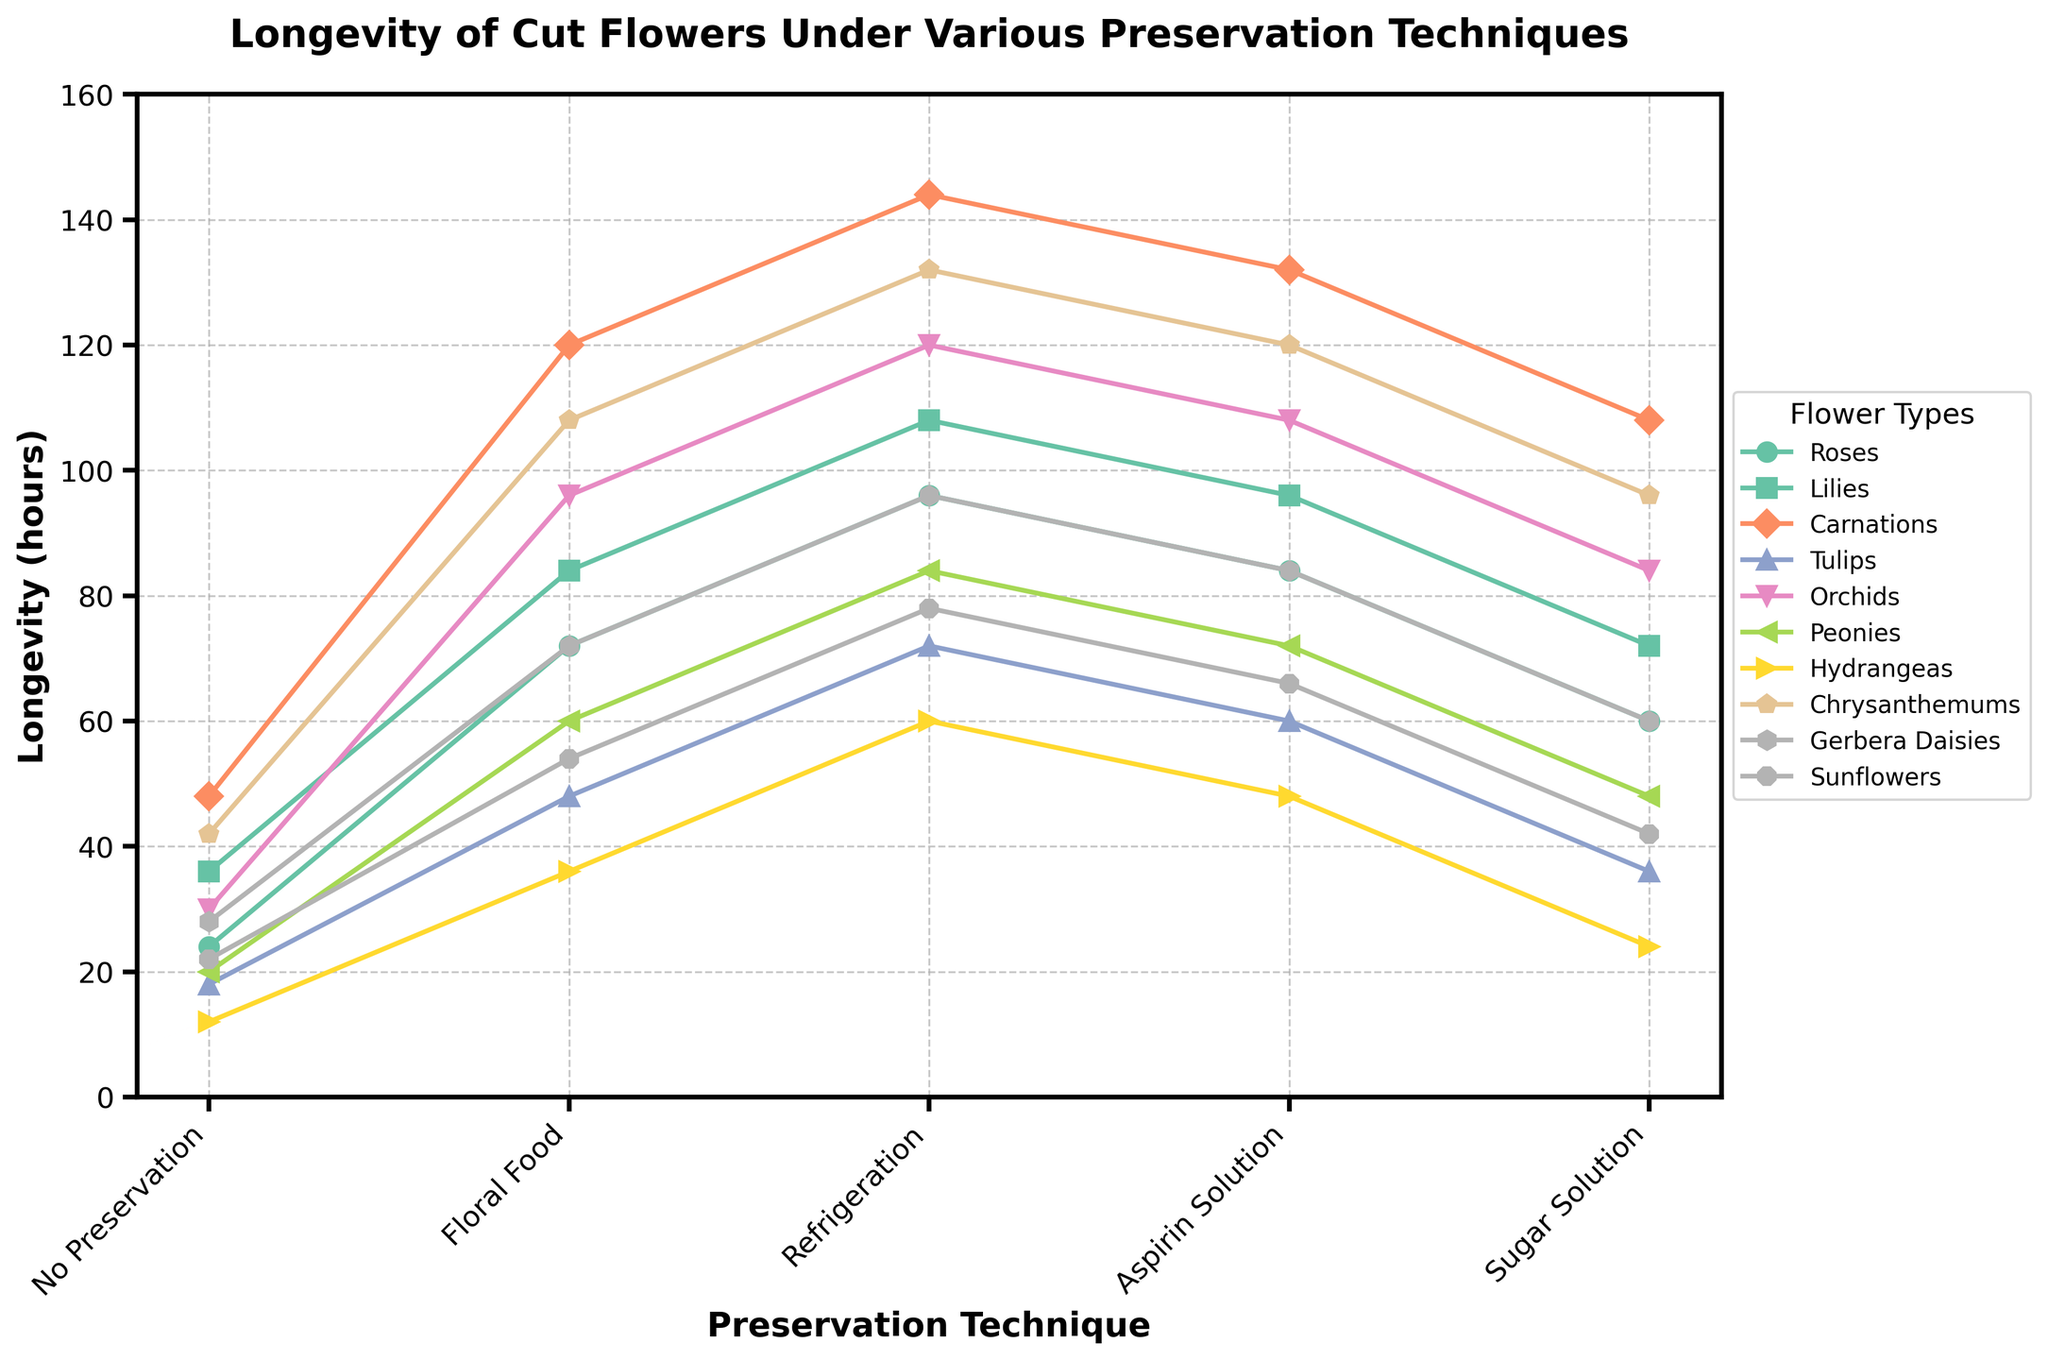Which flower type has the highest longevity with no preservation? Look at the section of the lines corresponding to 'No Preservation' and identify the flower type with the highest value. Carnations have the highest number, which is 48 hours.
Answer: Carnations Which technique provides the maximum longevity for Lilies? Refer to the line representing Lilies and find the peak value. The highest longevity for Lilies is 108 hours under Refrigeration.
Answer: Refrigeration What is the difference in longevity between Tulips with floral food and no preservation? Find the Tulips line, note values under floral food (48 hours) and no preservation (18 hours), and compute the difference: 48 - 18.
Answer: 30 hours Which preservation technique seems most effective overall? Compare the peaks of all preservation techniques; Refrigeration displays the highest values consistently for most flowers.
Answer: Refrigeration Calculate the average longevity of Roses across all preservation techniques. Sum the longevity values for Roses under each technique (24 + 72 + 96 + 84 + 60) = 336. Divide by the number of techniques (336/5).
Answer: 67.2 hours Do Sunflowers last longer with a sugar solution or refrigeration? For the Sunflower line, compare values under sugar solution (42 hours) vs refrigeration (78 hours). Refrigeration provides longer longevity.
Answer: Refrigeration Which flower type shows the greatest improvement in longevity when using refrigeration as opposed to no preservation? Subtract no preservation value from refrigeration for each flower type, and find the maximum difference. For Hydrangeas, this difference is the greatest: 60 - 12 = 48 hours.
Answer: Hydrangeas On average, how much longer do Carnations last under refrigeration compared to no preservation? Subtract the longevities for no preservation from refrigeration for Carnations: 144 - 48 = 96 hours.
Answer: 96 hours What is the median longevity for Orchids across all preservation methods? List longevities of Orchids: 30, 96, 120, 108, 84, then find the median value. The median value is the third number in the ordered list, which is 96.
Answer: 96 hours 